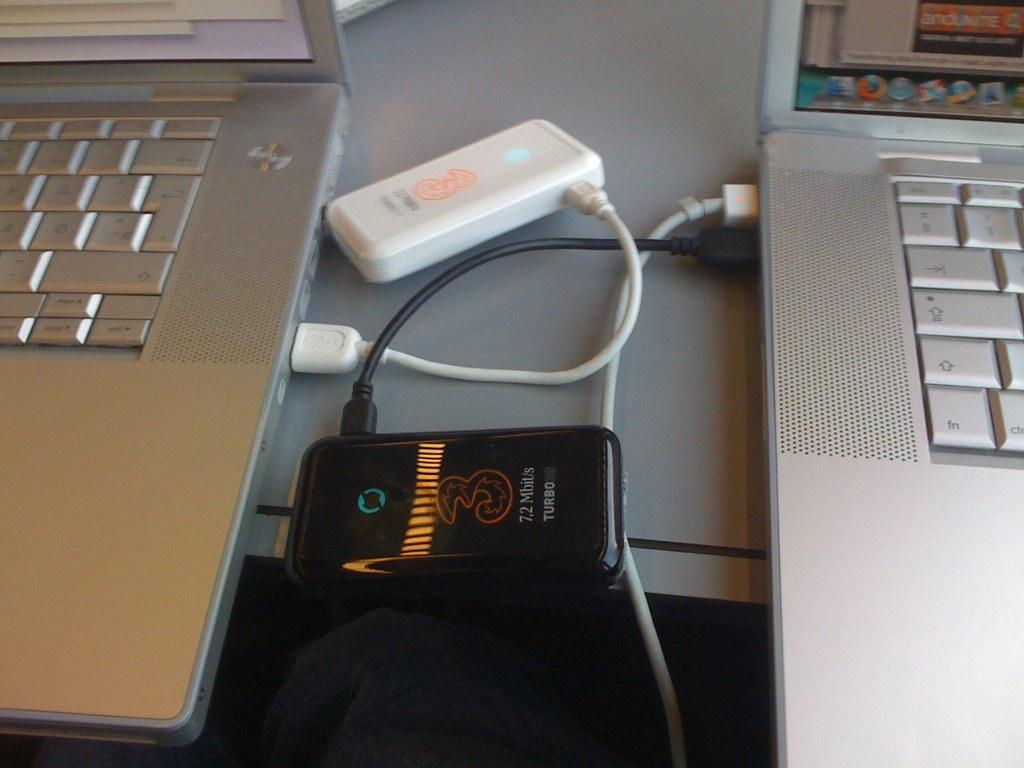<image>
Offer a succinct explanation of the picture presented. A turbo device is connected to the laptop 